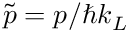Convert formula to latex. <formula><loc_0><loc_0><loc_500><loc_500>\tilde { p } = p / \hbar { k } _ { L }</formula> 